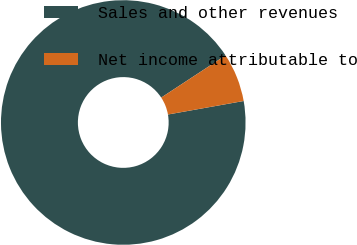Convert chart. <chart><loc_0><loc_0><loc_500><loc_500><pie_chart><fcel>Sales and other revenues<fcel>Net income attributable to<nl><fcel>93.57%<fcel>6.43%<nl></chart> 